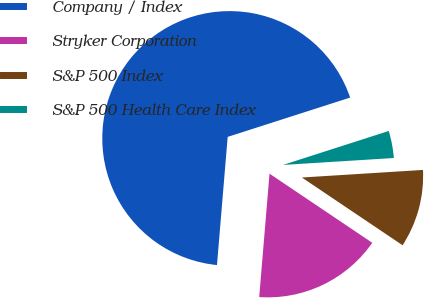Convert chart to OTSL. <chart><loc_0><loc_0><loc_500><loc_500><pie_chart><fcel>Company / Index<fcel>Stryker Corporation<fcel>S&P 500 Index<fcel>S&P 500 Health Care Index<nl><fcel>68.73%<fcel>16.9%<fcel>10.42%<fcel>3.95%<nl></chart> 